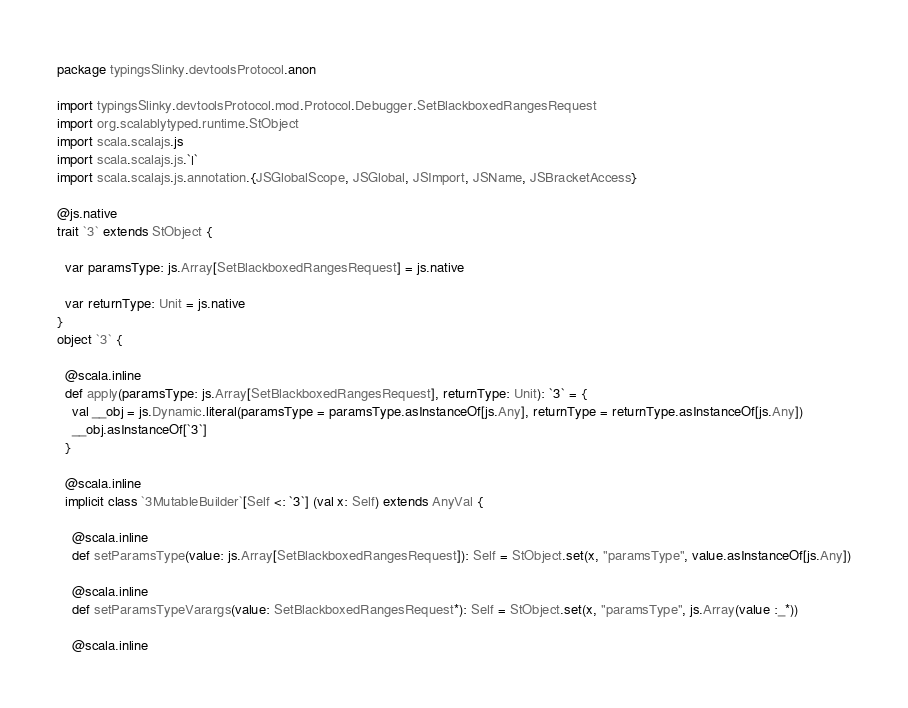<code> <loc_0><loc_0><loc_500><loc_500><_Scala_>package typingsSlinky.devtoolsProtocol.anon

import typingsSlinky.devtoolsProtocol.mod.Protocol.Debugger.SetBlackboxedRangesRequest
import org.scalablytyped.runtime.StObject
import scala.scalajs.js
import scala.scalajs.js.`|`
import scala.scalajs.js.annotation.{JSGlobalScope, JSGlobal, JSImport, JSName, JSBracketAccess}

@js.native
trait `3` extends StObject {
  
  var paramsType: js.Array[SetBlackboxedRangesRequest] = js.native
  
  var returnType: Unit = js.native
}
object `3` {
  
  @scala.inline
  def apply(paramsType: js.Array[SetBlackboxedRangesRequest], returnType: Unit): `3` = {
    val __obj = js.Dynamic.literal(paramsType = paramsType.asInstanceOf[js.Any], returnType = returnType.asInstanceOf[js.Any])
    __obj.asInstanceOf[`3`]
  }
  
  @scala.inline
  implicit class `3MutableBuilder`[Self <: `3`] (val x: Self) extends AnyVal {
    
    @scala.inline
    def setParamsType(value: js.Array[SetBlackboxedRangesRequest]): Self = StObject.set(x, "paramsType", value.asInstanceOf[js.Any])
    
    @scala.inline
    def setParamsTypeVarargs(value: SetBlackboxedRangesRequest*): Self = StObject.set(x, "paramsType", js.Array(value :_*))
    
    @scala.inline</code> 